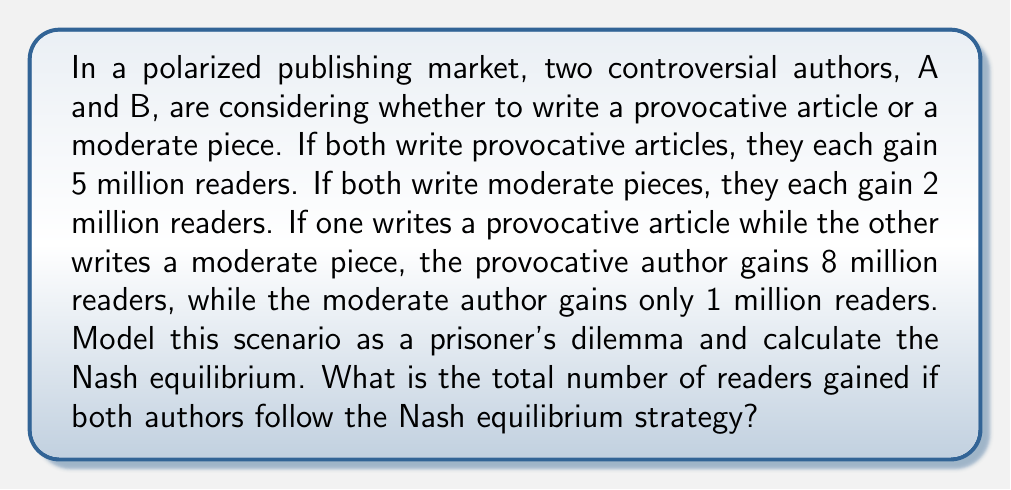Teach me how to tackle this problem. To model this scenario as a prisoner's dilemma and find the Nash equilibrium, we need to follow these steps:

1. Create a payoff matrix:
   Let P represent "write provocative article" and M represent "write moderate piece"

   $$
   \begin{array}{c|c|c}
    & B: P & B: M \\
   \hline
   A: P & (5, 5) & (8, 1) \\
   \hline
   A: M & (1, 8) & (2, 2)
   \end{array}
   $$

2. Analyze the dominant strategies:
   For Author A:
   - If B chooses P: 5 > 1, so A prefers P
   - If B chooses M: 8 > 2, so A prefers P
   Therefore, P is the dominant strategy for A

   For Author B:
   - If A chooses P: 5 > 1, so B prefers P
   - If A chooses M: 8 > 2, so B prefers P
   Therefore, P is the dominant strategy for B

3. Identify the Nash equilibrium:
   The Nash equilibrium occurs when both authors choose their dominant strategy, which is to write a provocative article (P, P).

4. Calculate the total number of readers:
   At the Nash equilibrium (P, P), each author gains 5 million readers.
   Total readers = 5 million + 5 million = 10 million

This scenario demonstrates a classic prisoner's dilemma because:
- The dominant strategy for both authors is to write provocative articles
- The Nash equilibrium (P, P) is not Pareto optimal, as (M, M) would yield a better outcome for both authors
- There's a conflict between individual rationality (choosing P) and group rationality (both choosing M)
Answer: The total number of readers gained if both authors follow the Nash equilibrium strategy is 10 million. 